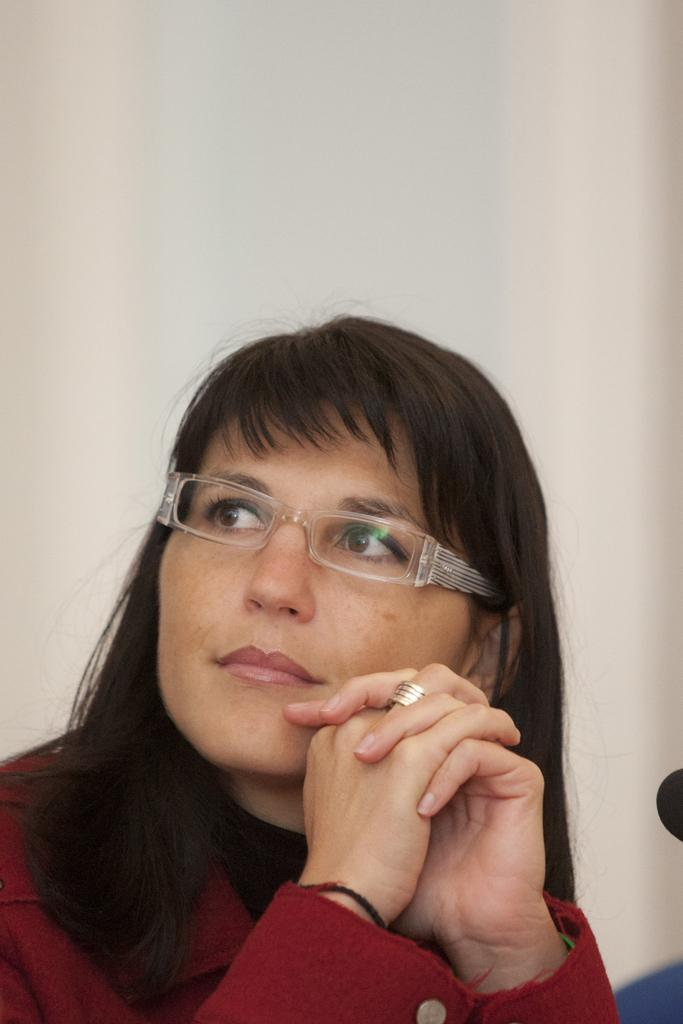Who is the main subject in the image? There is a woman in the image. What is the woman wearing in the image? The woman is wearing a maroon color dress and spectacles. What is the color of the background in the image? The background of the image is white. What type of art can be seen in the background of the image? There is no art present in the background of the image; it is a plain white background. Can you hear any thunder in the image? There is no sound in the image, so it is not possible to hear any thunder. 